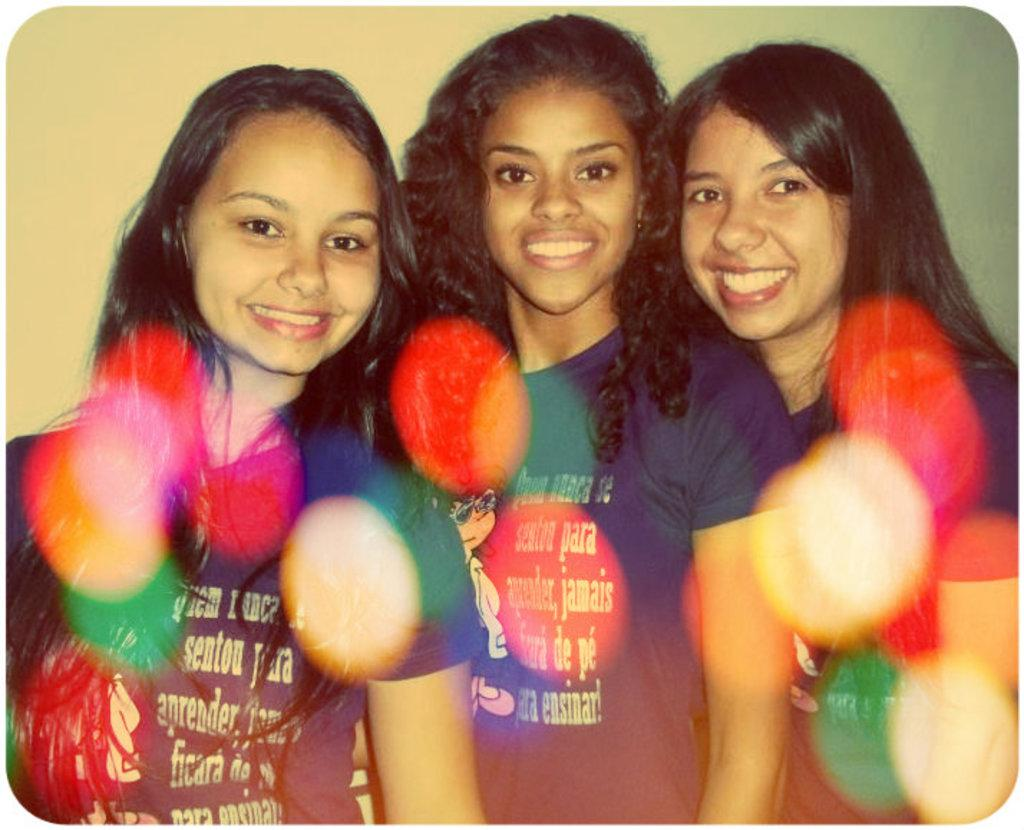How many girls are in the image? There are three girls in the image. What expression do the girls have? The girls are smiling. What type of clothing are the girls wearing? The girls are wearing t-shirts. What can be seen in the background of the image? There is a wall in the background of the image. What is written or printed on the t-shirts? There is text on the t-shirts. What type of brass instrument is the girl playing in the image? There is no brass instrument or girl playing an instrument in the image. How many clouds are visible in the image? There are no clouds visible in the image; it features three girls and a wall in the background. 